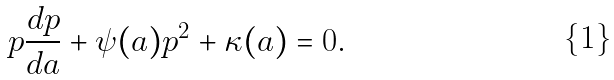<formula> <loc_0><loc_0><loc_500><loc_500>p \frac { d p } { d a } + \psi ( a ) p ^ { 2 } + \kappa ( a ) = 0 .</formula> 